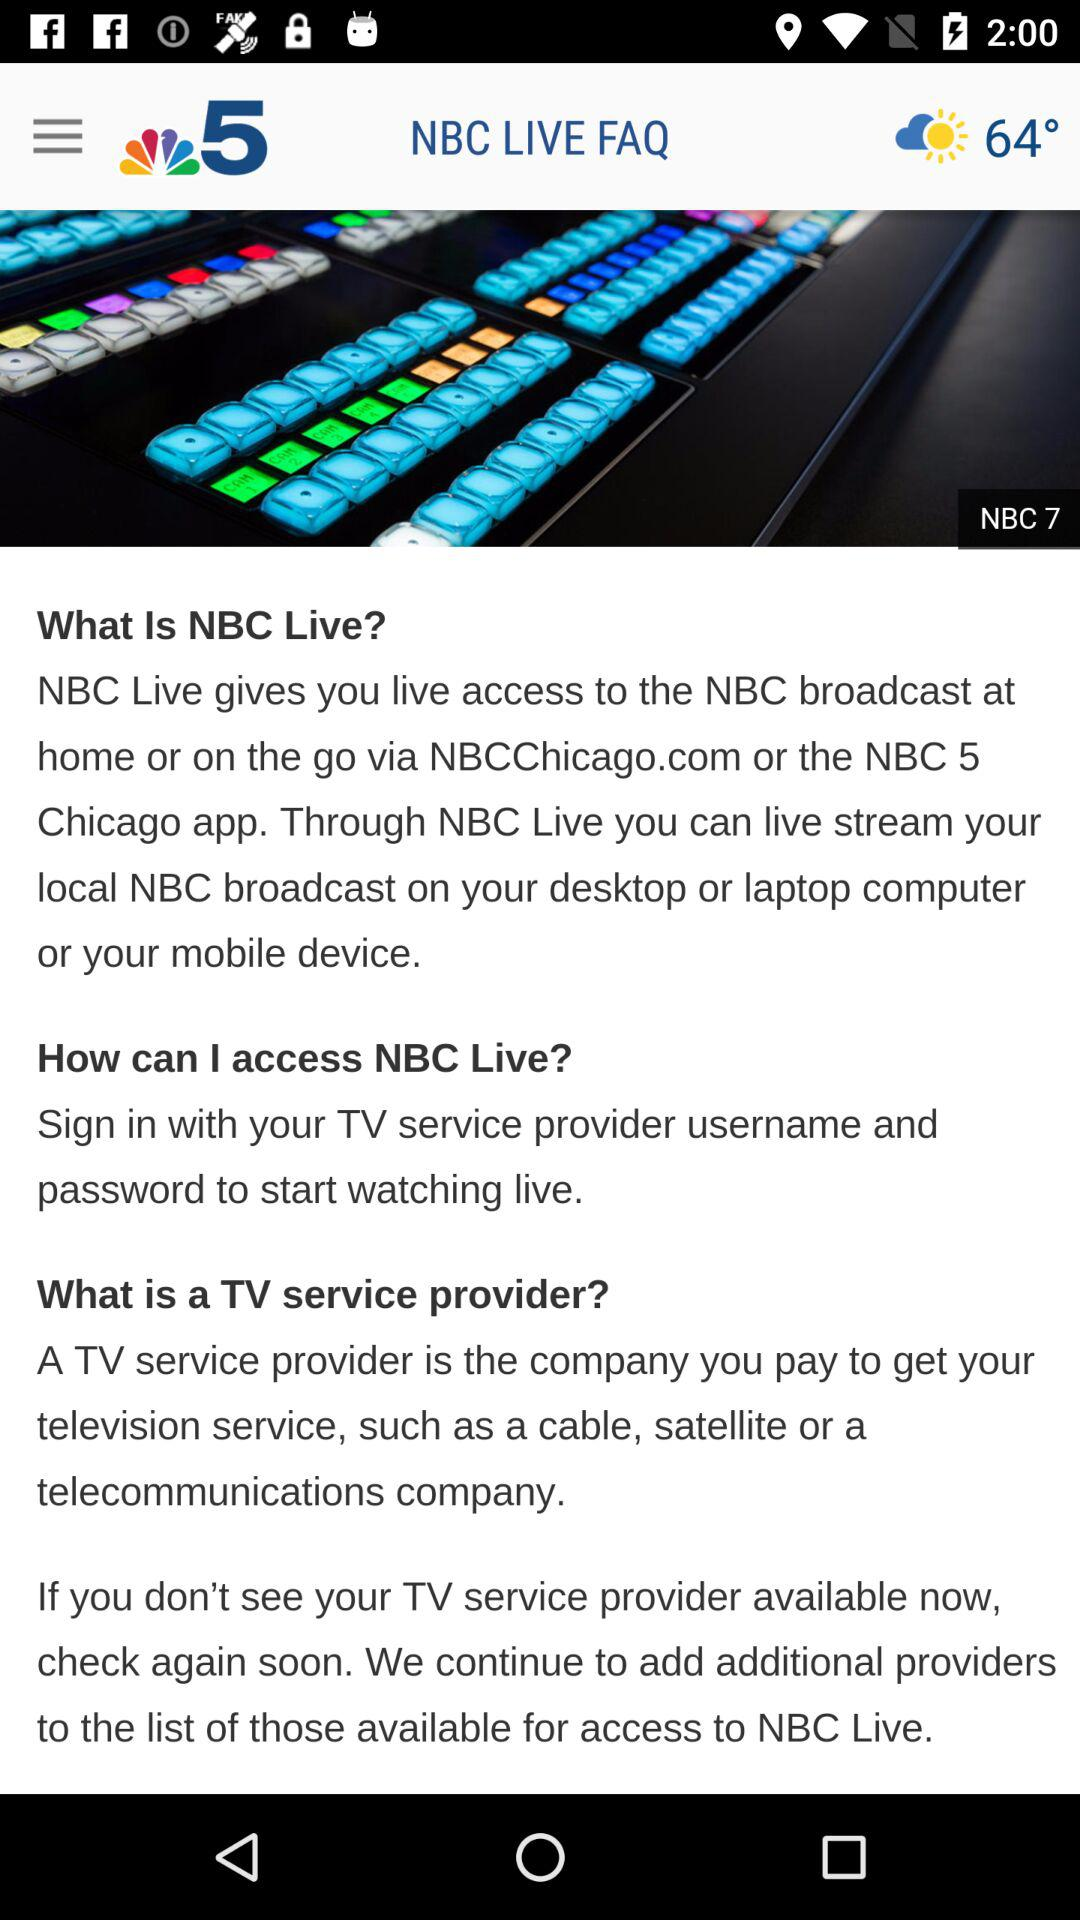What is the application name? The application name is "NBC 5 Chicago". 